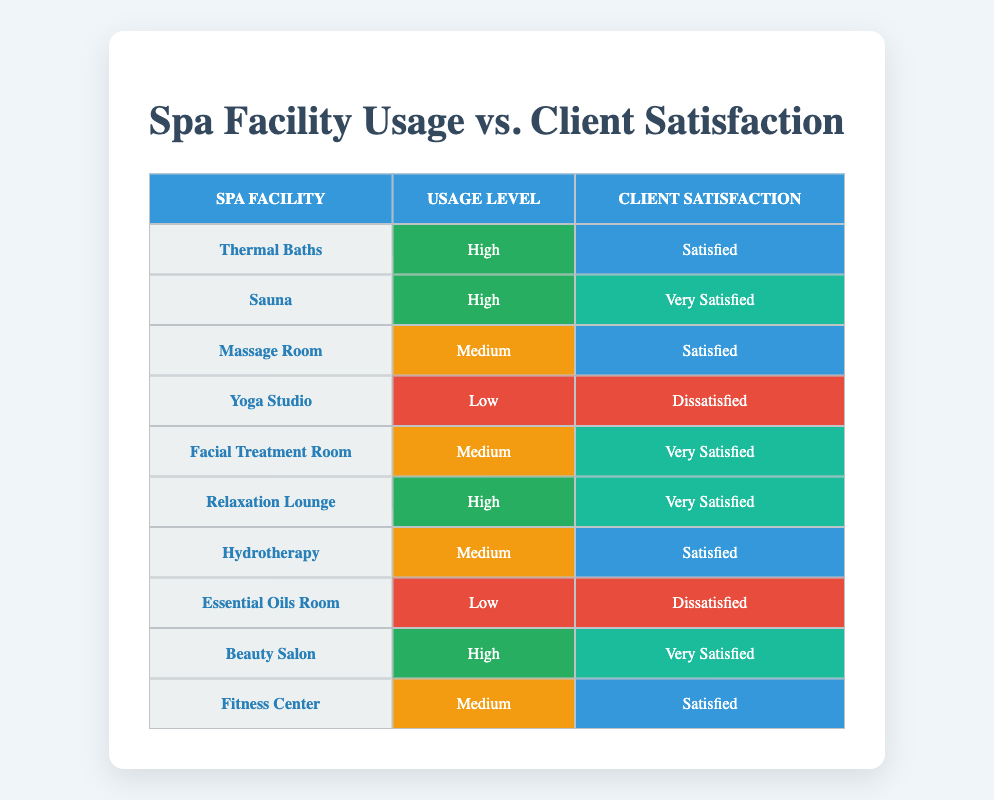What spa facility has the highest client satisfaction level? The spa facility with the highest client satisfaction level is the Sauna, which has a client satisfaction rating of "Very Satisfied". This can be directly identified from the table where the Sauna's corresponding column states "Very Satisfied".
Answer: Sauna How many spa facilities have high usage and report being satisfied? There are two facilities that have a high usage level and report a client satisfaction of "Satisfied": Thermal Baths and one facility that has a high usage level but has a higher satisfaction—Sauna, which is very satisfied. Hence, only Thermal Baths fits the criteria.
Answer: 1 Are there any facilities with low usage that report being satisfied? No, there are no facilities listed with low usage that report a client satisfaction of "Satisfied". The facilities with low usage (Yoga Studio and Essential Oils Room) report being "Dissatisfied".
Answer: No What is the average usage level for facilities rated as "Very Satisfied"? Facilities that are rated as "Very Satisfied" (Sauna, Facial Treatment Room, Relaxation Lounge, and Beauty Salon) include two high (Sauna, Relaxation Lounge, and Beauty Salon), and one medium (Facial Treatment Room). Therefore, the average usage level can be categorized as high (3) and medium (1), making the average value for the count of categories would be (3+1)/4 = 1.5, thus leaning towards high usage.
Answer: High How many spa facilities have reported dissatisfaction? There are two facilities that reported dissatisfaction: Yoga Studio and Essential Oils Room—both having a client satisfaction level of "Dissatisfied". This can be verified by checking the satisfaction column for those two facilities.
Answer: 2 What percentage of high usage facilities report being very satisfied? There are four high usage facilities (Thermal Baths, Sauna, Relaxation Lounge, and Beauty Salon) and three of them (Sauna, Relaxation Lounge, and Beauty Salon) report "Very Satisfied". Therefore, the percentage is (3/4) * 100 = 75%.
Answer: 75% Which facilities have a medium usage level but are very satisfied? The only facility with medium usage and a satisfaction level of "Very Satisfied" is the Facial Treatment Room. This is identified by scanning the usage level and the corresponding satisfaction rating in the table.
Answer: Facial Treatment Room Does the Fitness Center receive a higher or lower satisfaction than the Yoga Studio? The Fitness Center has a satisfaction rating of "Satisfied" while the Yoga Studio is "Dissatisfied". Therefore, the Fitness Center has a higher level of satisfaction than the Yoga Studio.
Answer: Higher 